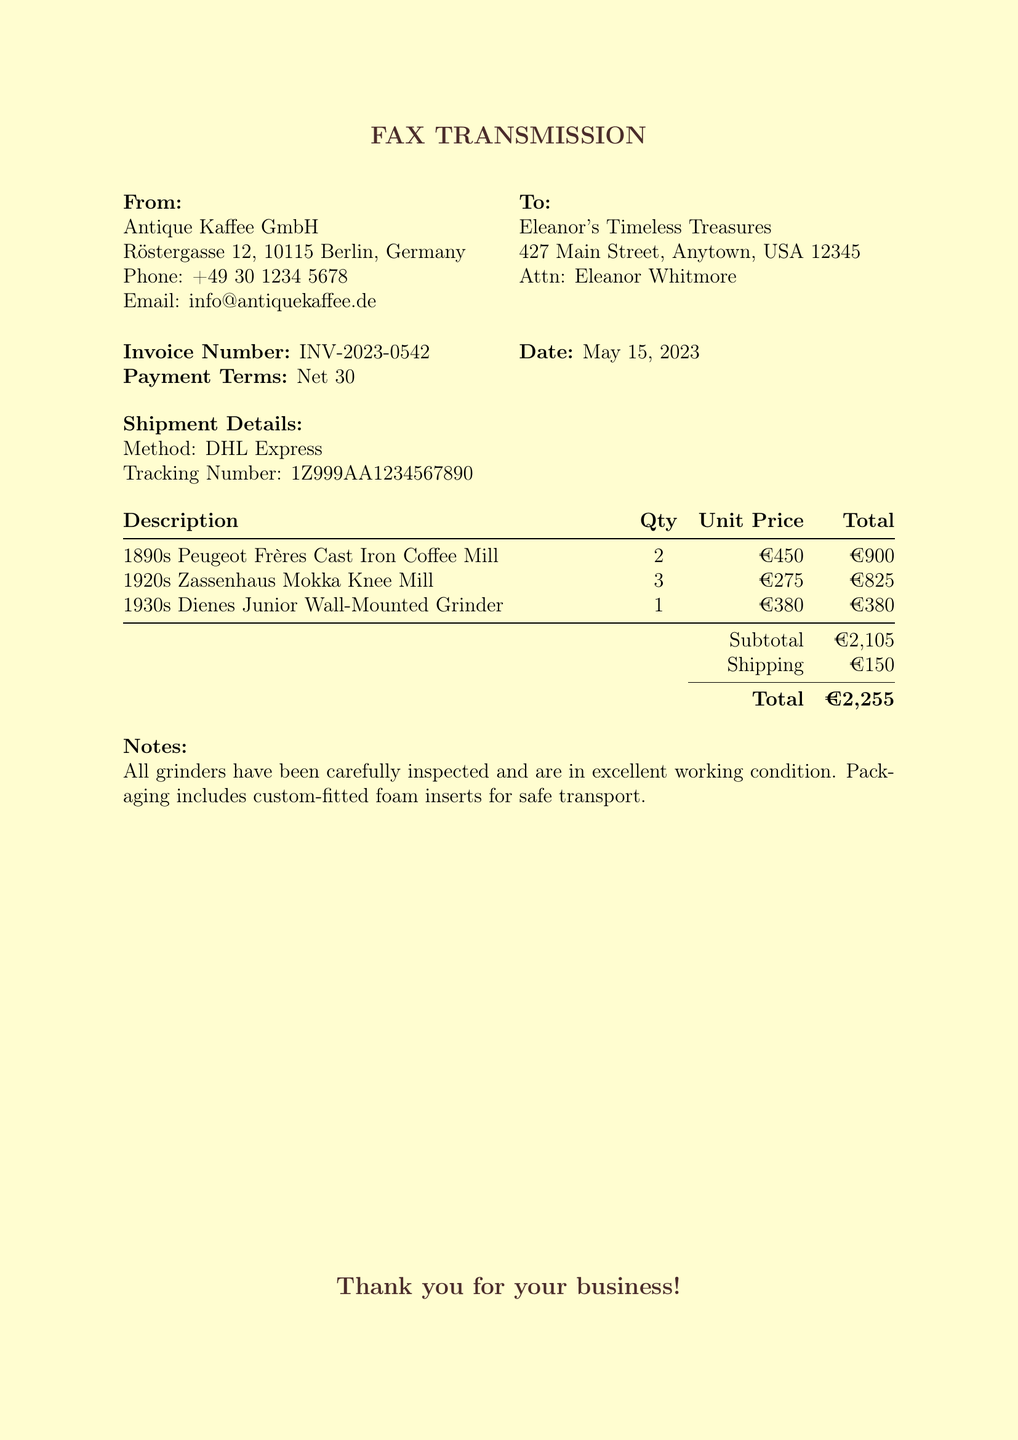What is the invoice number? The invoice number is stated in the document and is a unique identifier for the transaction.
Answer: INV-2023-0542 What is the date of the invoice? The date indicates when the invoice was issued, which is clearly mentioned in the document.
Answer: May 15, 2023 How many Peugeot Frères coffee mills were ordered? The quantity ordered for each item is shown in a list, allowing for easy retrieval of this information.
Answer: 2 What are the payment terms? Payment terms specify how long the buyer has to pay, which is detailed in the document.
Answer: Net 30 What is the subtotal amount? The subtotal is the sum of all item totals before any additional charges, clearly listed in the invoice.
Answer: €2,105 What shipping method was used for the order? The shipment details provide information about the shipping method used for this order.
Answer: DHL Express How much was the shipping cost? The cost of shipping is explicitly mentioned in the breakdown of the invoice.
Answer: €150 How many total coffee grinders were ordered? To find the total, one must add the quantities of each specific item ordered, provided in the document.
Answer: 6 What is the total invoice amount? The total invoice amount is provided at the end of the financial details section of the document.
Answer: €2,255 